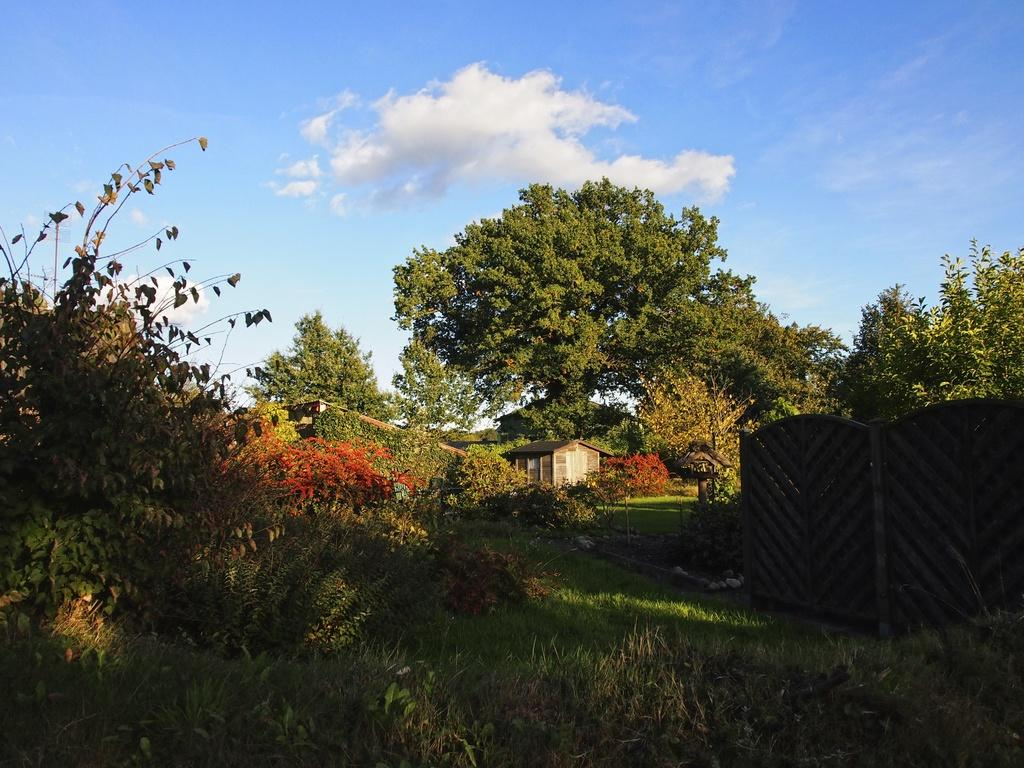What type of vegetation can be seen in the image? There is grass, plants, and trees in the image. What type of structures are present in the image? There are houses in the image. What is the boundary between the grass and the houses? There is a fence in the image. What is visible in the background of the image? The sky is visible in the image. Can you determine the time of day the image was taken? The image was likely taken during the day, as the sky is visible and not dark. What type of fruit is hanging from the trees in the image? There is no fruit visible in the image; only trees, houses, grass, and a fence are present. What is the size of the minister in the image? There is no minister present in the image. 